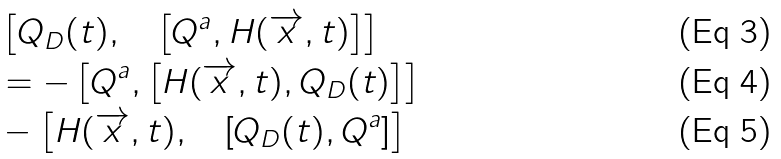<formula> <loc_0><loc_0><loc_500><loc_500>& \left [ Q _ { D } ( t ) , \quad \left [ Q ^ { a } , H ( \overrightarrow { x } , t ) \right ] \right ] \\ & = - \left [ Q ^ { a } , \left [ H ( \overrightarrow { x } , t ) , Q _ { D } ( t ) \right ] \right ] \\ & - \left [ H ( \overrightarrow { x } , t ) , \quad \left [ Q _ { D } ( t ) , Q ^ { a } \right ] \right ]</formula> 